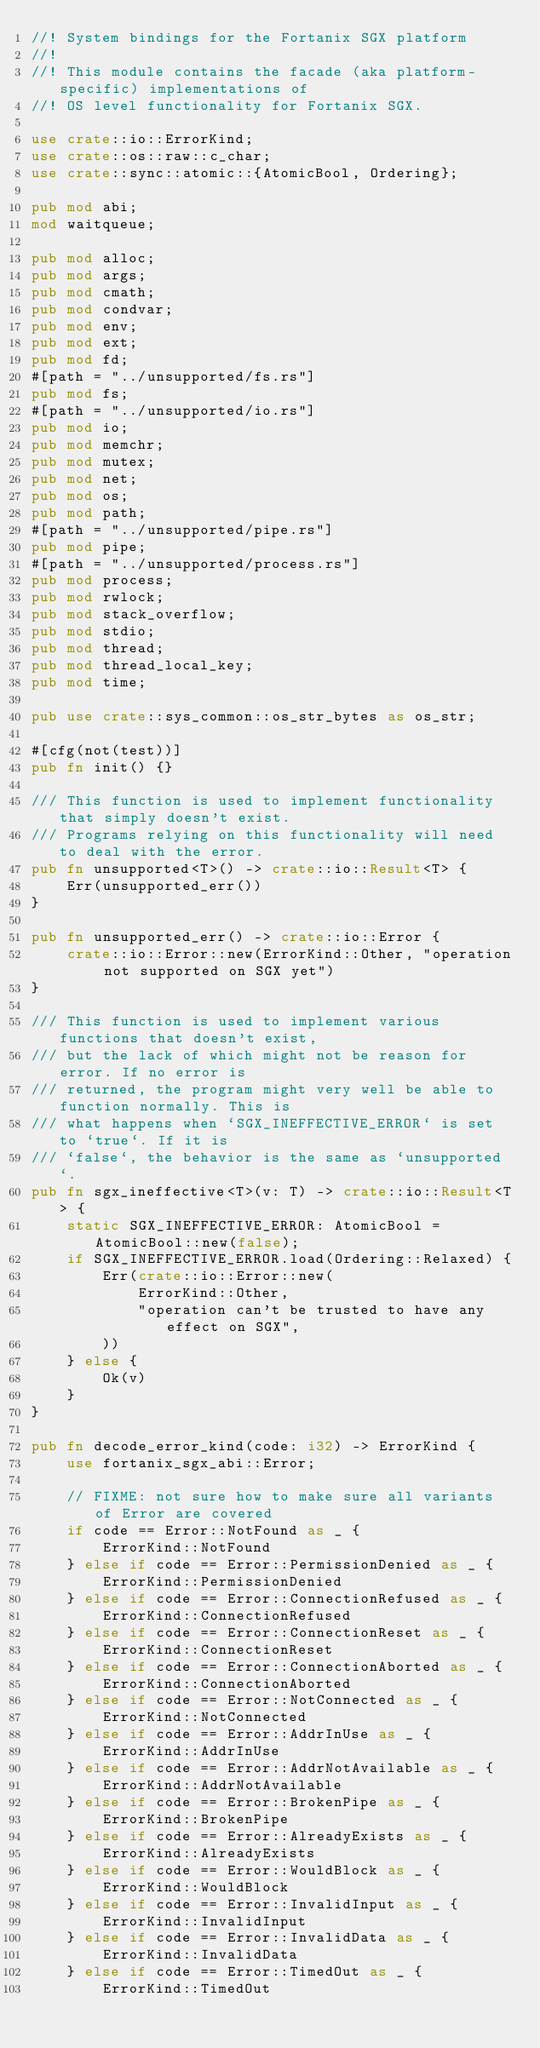<code> <loc_0><loc_0><loc_500><loc_500><_Rust_>//! System bindings for the Fortanix SGX platform
//!
//! This module contains the facade (aka platform-specific) implementations of
//! OS level functionality for Fortanix SGX.

use crate::io::ErrorKind;
use crate::os::raw::c_char;
use crate::sync::atomic::{AtomicBool, Ordering};

pub mod abi;
mod waitqueue;

pub mod alloc;
pub mod args;
pub mod cmath;
pub mod condvar;
pub mod env;
pub mod ext;
pub mod fd;
#[path = "../unsupported/fs.rs"]
pub mod fs;
#[path = "../unsupported/io.rs"]
pub mod io;
pub mod memchr;
pub mod mutex;
pub mod net;
pub mod os;
pub mod path;
#[path = "../unsupported/pipe.rs"]
pub mod pipe;
#[path = "../unsupported/process.rs"]
pub mod process;
pub mod rwlock;
pub mod stack_overflow;
pub mod stdio;
pub mod thread;
pub mod thread_local_key;
pub mod time;

pub use crate::sys_common::os_str_bytes as os_str;

#[cfg(not(test))]
pub fn init() {}

/// This function is used to implement functionality that simply doesn't exist.
/// Programs relying on this functionality will need to deal with the error.
pub fn unsupported<T>() -> crate::io::Result<T> {
    Err(unsupported_err())
}

pub fn unsupported_err() -> crate::io::Error {
    crate::io::Error::new(ErrorKind::Other, "operation not supported on SGX yet")
}

/// This function is used to implement various functions that doesn't exist,
/// but the lack of which might not be reason for error. If no error is
/// returned, the program might very well be able to function normally. This is
/// what happens when `SGX_INEFFECTIVE_ERROR` is set to `true`. If it is
/// `false`, the behavior is the same as `unsupported`.
pub fn sgx_ineffective<T>(v: T) -> crate::io::Result<T> {
    static SGX_INEFFECTIVE_ERROR: AtomicBool = AtomicBool::new(false);
    if SGX_INEFFECTIVE_ERROR.load(Ordering::Relaxed) {
        Err(crate::io::Error::new(
            ErrorKind::Other,
            "operation can't be trusted to have any effect on SGX",
        ))
    } else {
        Ok(v)
    }
}

pub fn decode_error_kind(code: i32) -> ErrorKind {
    use fortanix_sgx_abi::Error;

    // FIXME: not sure how to make sure all variants of Error are covered
    if code == Error::NotFound as _ {
        ErrorKind::NotFound
    } else if code == Error::PermissionDenied as _ {
        ErrorKind::PermissionDenied
    } else if code == Error::ConnectionRefused as _ {
        ErrorKind::ConnectionRefused
    } else if code == Error::ConnectionReset as _ {
        ErrorKind::ConnectionReset
    } else if code == Error::ConnectionAborted as _ {
        ErrorKind::ConnectionAborted
    } else if code == Error::NotConnected as _ {
        ErrorKind::NotConnected
    } else if code == Error::AddrInUse as _ {
        ErrorKind::AddrInUse
    } else if code == Error::AddrNotAvailable as _ {
        ErrorKind::AddrNotAvailable
    } else if code == Error::BrokenPipe as _ {
        ErrorKind::BrokenPipe
    } else if code == Error::AlreadyExists as _ {
        ErrorKind::AlreadyExists
    } else if code == Error::WouldBlock as _ {
        ErrorKind::WouldBlock
    } else if code == Error::InvalidInput as _ {
        ErrorKind::InvalidInput
    } else if code == Error::InvalidData as _ {
        ErrorKind::InvalidData
    } else if code == Error::TimedOut as _ {
        ErrorKind::TimedOut</code> 